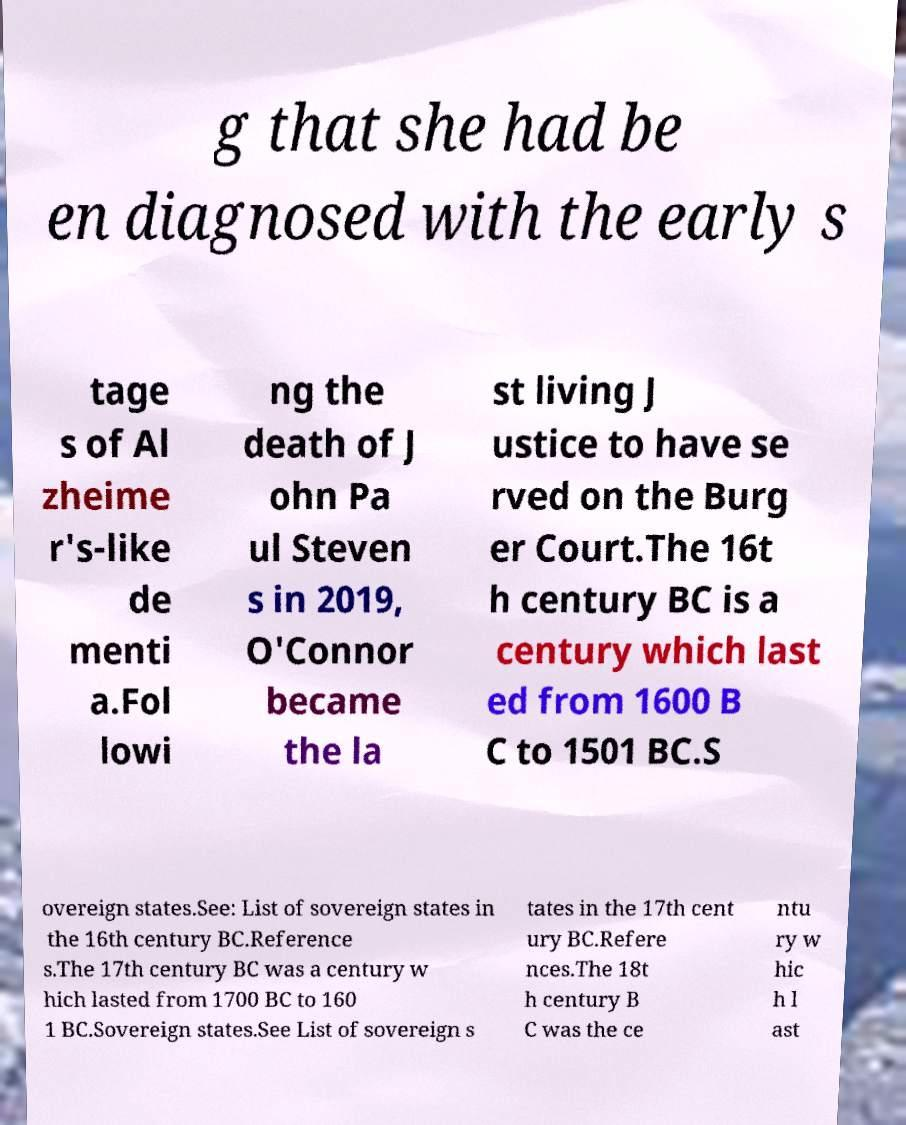What messages or text are displayed in this image? I need them in a readable, typed format. g that she had be en diagnosed with the early s tage s of Al zheime r's-like de menti a.Fol lowi ng the death of J ohn Pa ul Steven s in 2019, O'Connor became the la st living J ustice to have se rved on the Burg er Court.The 16t h century BC is a century which last ed from 1600 B C to 1501 BC.S overeign states.See: List of sovereign states in the 16th century BC.Reference s.The 17th century BC was a century w hich lasted from 1700 BC to 160 1 BC.Sovereign states.See List of sovereign s tates in the 17th cent ury BC.Refere nces.The 18t h century B C was the ce ntu ry w hic h l ast 